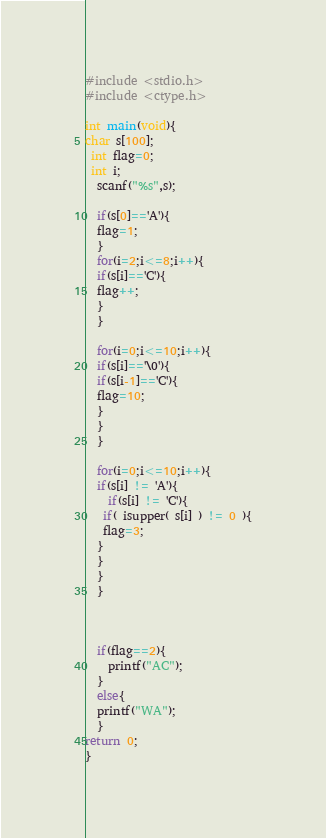Convert code to text. <code><loc_0><loc_0><loc_500><loc_500><_C_>#include <stdio.h>
#include <ctype.h>

int main(void){
char s[100];
 int flag=0; 
 int i; 
  scanf("%s",s);
  
  if(s[0]=='A'){
  flag=1;
  }
  for(i=2;i<=8;i++){
  if(s[i]=='C'){
  flag++;
  }
  }
  
  for(i=0;i<=10;i++){
  if(s[i]=='\0'){
  if(s[i-1]=='C'){
  flag=10;
  }
  }
  }
  
  for(i=0;i<=10;i++){
  if(s[i] != 'A'){
    if(s[i] != 'C'){
   if( isupper( s[i] ) != 0 ){
   flag=3;
  }
  }
  }
  }
  
  
  
  if(flag==2){
    printf("AC");
  }
  else{
  printf("WA");
  }
return 0;
}</code> 